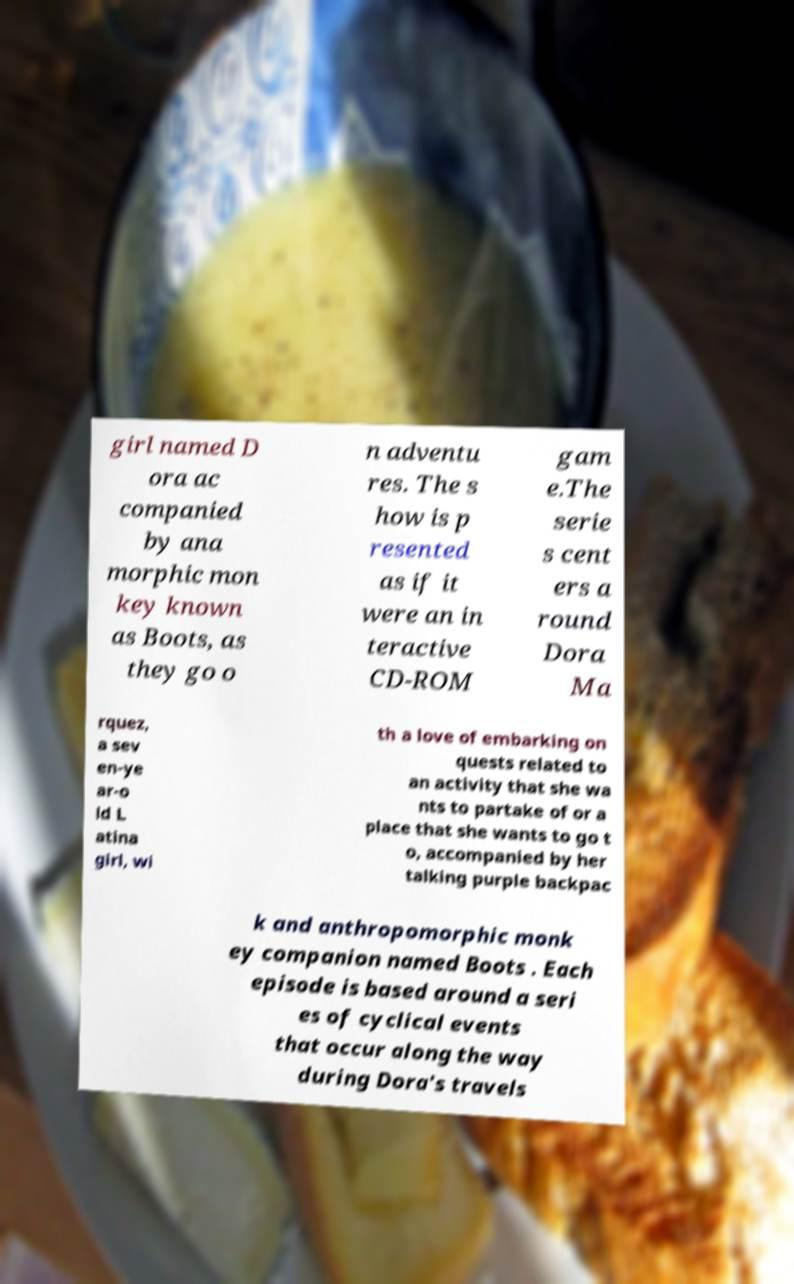Please read and relay the text visible in this image. What does it say? girl named D ora ac companied by ana morphic mon key known as Boots, as they go o n adventu res. The s how is p resented as if it were an in teractive CD-ROM gam e.The serie s cent ers a round Dora Ma rquez, a sev en-ye ar-o ld L atina girl, wi th a love of embarking on quests related to an activity that she wa nts to partake of or a place that she wants to go t o, accompanied by her talking purple backpac k and anthropomorphic monk ey companion named Boots . Each episode is based around a seri es of cyclical events that occur along the way during Dora's travels 